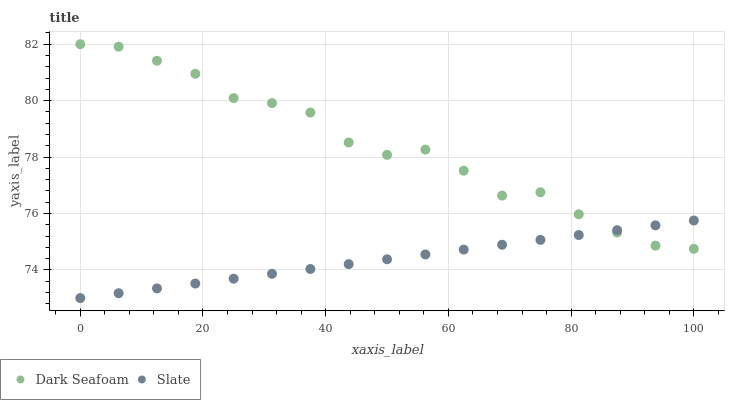Does Slate have the minimum area under the curve?
Answer yes or no. Yes. Does Dark Seafoam have the maximum area under the curve?
Answer yes or no. Yes. Does Slate have the maximum area under the curve?
Answer yes or no. No. Is Slate the smoothest?
Answer yes or no. Yes. Is Dark Seafoam the roughest?
Answer yes or no. Yes. Is Slate the roughest?
Answer yes or no. No. Does Slate have the lowest value?
Answer yes or no. Yes. Does Dark Seafoam have the highest value?
Answer yes or no. Yes. Does Slate have the highest value?
Answer yes or no. No. Does Slate intersect Dark Seafoam?
Answer yes or no. Yes. Is Slate less than Dark Seafoam?
Answer yes or no. No. Is Slate greater than Dark Seafoam?
Answer yes or no. No. 